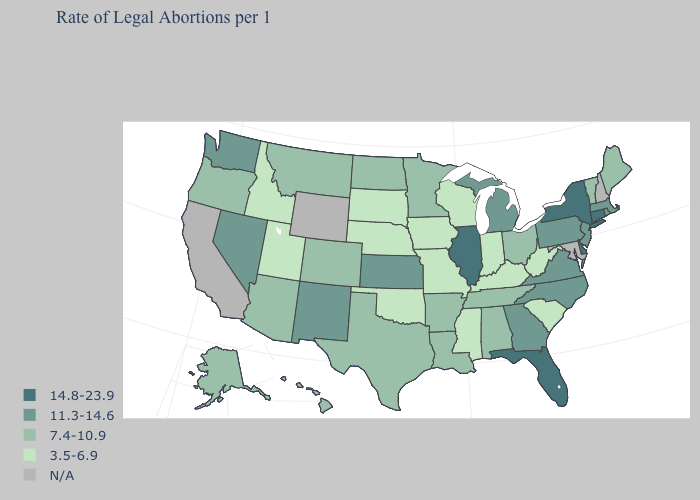Name the states that have a value in the range 3.5-6.9?
Quick response, please. Idaho, Indiana, Iowa, Kentucky, Mississippi, Missouri, Nebraska, Oklahoma, South Carolina, South Dakota, Utah, West Virginia, Wisconsin. What is the lowest value in states that border South Dakota?
Give a very brief answer. 3.5-6.9. What is the value of Minnesota?
Short answer required. 7.4-10.9. What is the value of Maine?
Quick response, please. 7.4-10.9. Name the states that have a value in the range 14.8-23.9?
Write a very short answer. Connecticut, Delaware, Florida, Illinois, New York. Among the states that border Arkansas , does Mississippi have the lowest value?
Concise answer only. Yes. Is the legend a continuous bar?
Answer briefly. No. Name the states that have a value in the range 7.4-10.9?
Keep it brief. Alabama, Alaska, Arizona, Arkansas, Colorado, Hawaii, Louisiana, Maine, Minnesota, Montana, North Dakota, Ohio, Oregon, Tennessee, Texas, Vermont. Among the states that border Connecticut , does New York have the lowest value?
Be succinct. No. What is the value of Pennsylvania?
Keep it brief. 11.3-14.6. What is the highest value in the MidWest ?
Write a very short answer. 14.8-23.9. What is the value of Michigan?
Write a very short answer. 11.3-14.6. What is the value of Iowa?
Quick response, please. 3.5-6.9. Does South Dakota have the highest value in the MidWest?
Answer briefly. No. Does South Carolina have the lowest value in the South?
Keep it brief. Yes. 